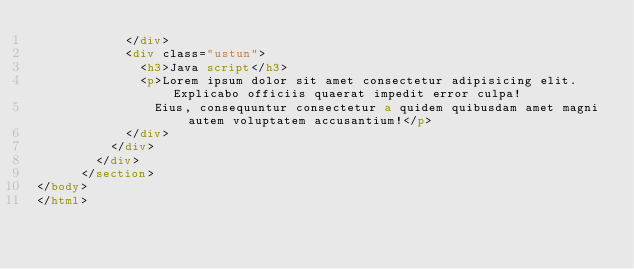<code> <loc_0><loc_0><loc_500><loc_500><_HTML_>            </div>
            <div class="ustun">
              <h3>Java script</h3>
              <p>Lorem ipsum dolor sit amet consectetur adipisicing elit. Explicabo officiis quaerat impedit error culpa!
                Eius, consequuntur consectetur a quidem quibusdam amet magni autem voluptatem accusantium!</p>
            </div>
          </div>
        </div>
      </section>
</body>
</html></code> 